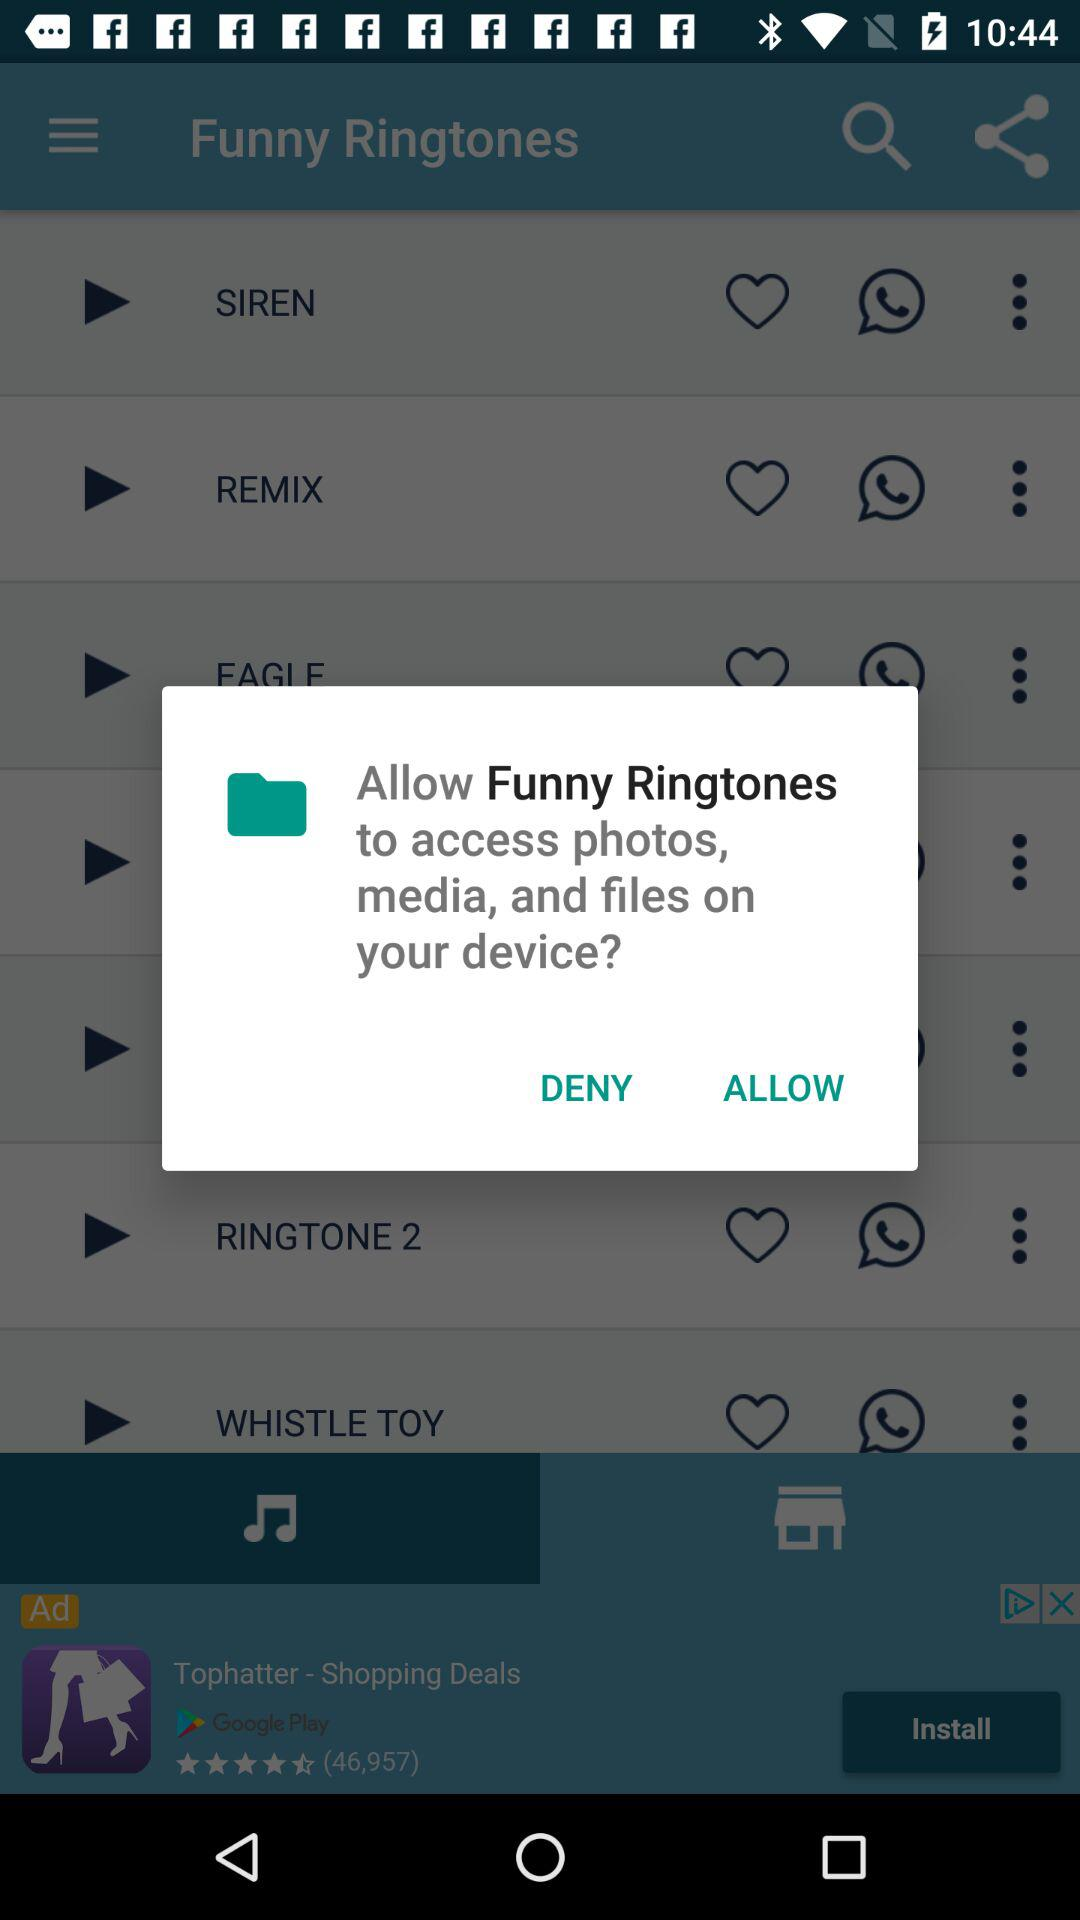What is the name of the application? The application name is "Funny Ringtones". 